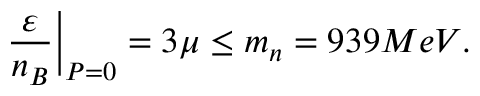<formula> <loc_0><loc_0><loc_500><loc_500>\frac { \varepsilon } { n _ { B } } \Big | _ { P = 0 } = 3 \mu \leq m _ { n } = 9 3 9 M e V .</formula> 